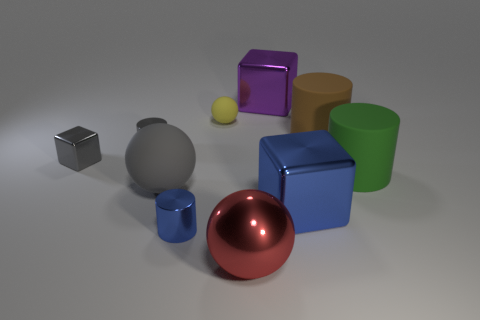There is a green thing that is made of the same material as the gray ball; what shape is it? cylinder 